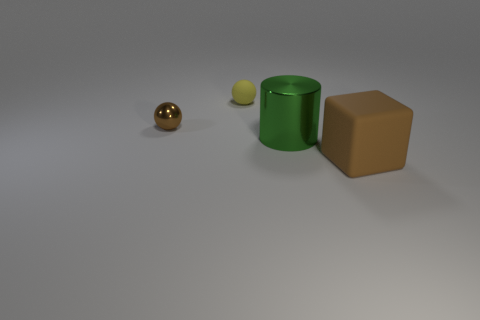There is a large matte object; is it the same color as the ball that is left of the small yellow matte ball?
Provide a short and direct response. Yes. What color is the big cylinder?
Your answer should be very brief. Green. Are there any objects to the right of the brown shiny sphere?
Make the answer very short. Yes. Is the large matte cube the same color as the metallic ball?
Your answer should be compact. Yes. What number of balls are the same color as the matte block?
Provide a succinct answer. 1. What is the size of the thing to the left of the small ball on the right side of the small brown thing?
Give a very brief answer. Small. What shape is the big shiny object?
Provide a short and direct response. Cylinder. What is the big object in front of the big cylinder made of?
Your answer should be compact. Rubber. There is a large thing behind the big object that is on the right side of the metal object that is on the right side of the small brown metal sphere; what color is it?
Provide a short and direct response. Green. The other metallic thing that is the same size as the yellow thing is what color?
Provide a short and direct response. Brown. 